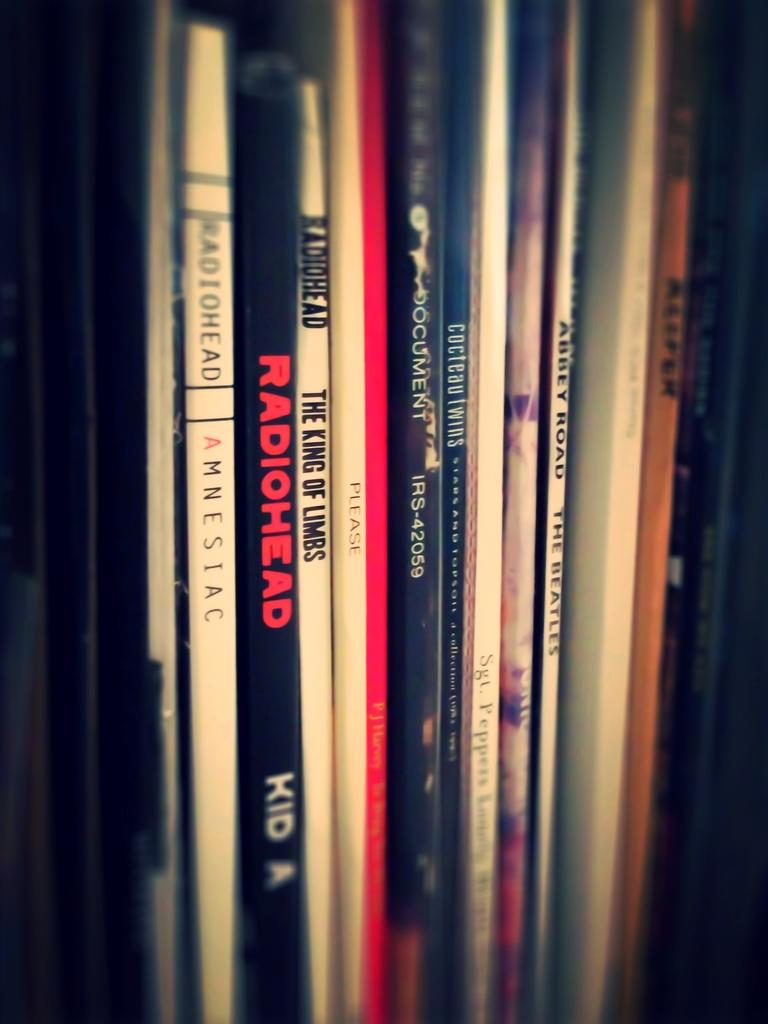<image>
Render a clear and concise summary of the photo. Books on a shelf include several on Radiohead. 